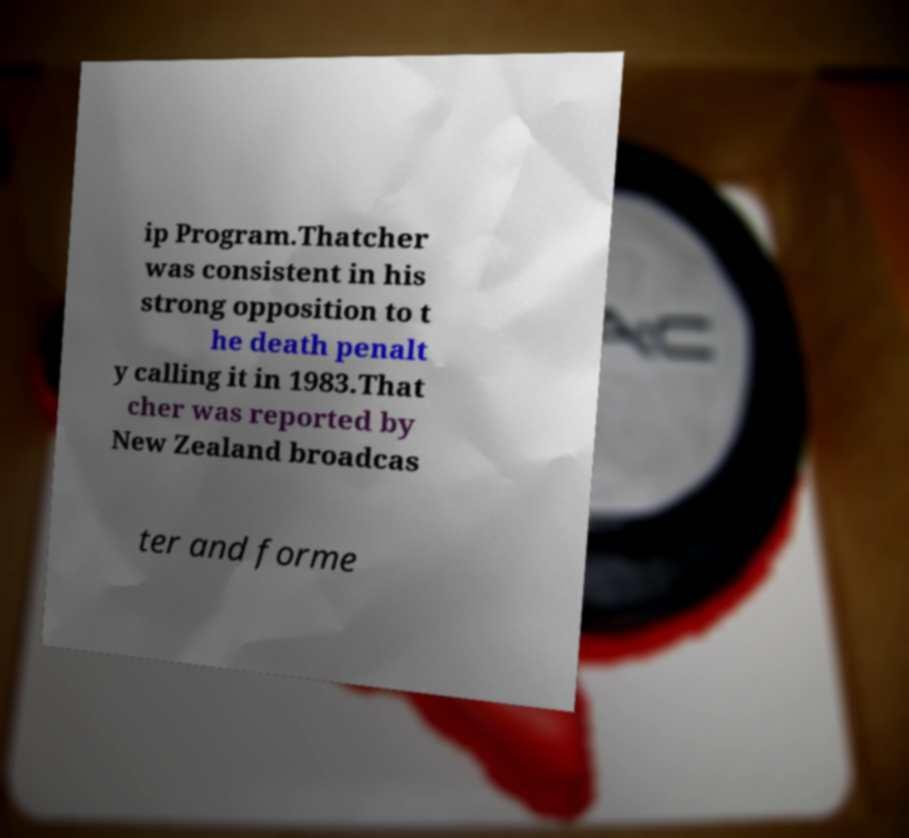I need the written content from this picture converted into text. Can you do that? ip Program.Thatcher was consistent in his strong opposition to t he death penalt y calling it in 1983.That cher was reported by New Zealand broadcas ter and forme 